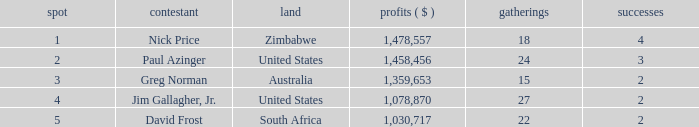How many events have earnings less than 1,030,717? 0.0. 